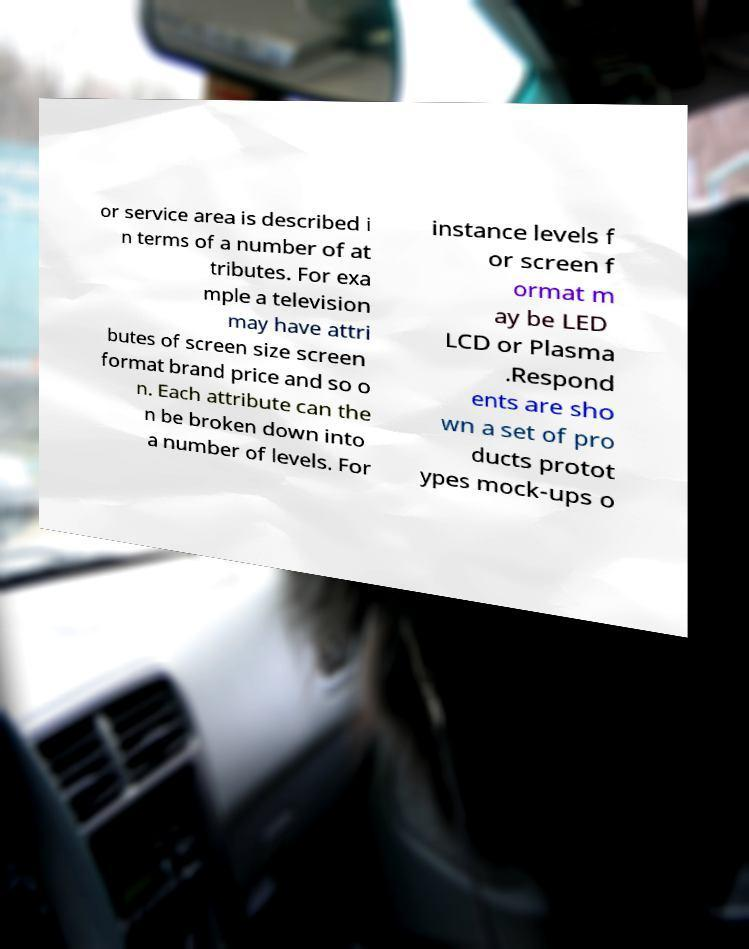For documentation purposes, I need the text within this image transcribed. Could you provide that? or service area is described i n terms of a number of at tributes. For exa mple a television may have attri butes of screen size screen format brand price and so o n. Each attribute can the n be broken down into a number of levels. For instance levels f or screen f ormat m ay be LED LCD or Plasma .Respond ents are sho wn a set of pro ducts protot ypes mock-ups o 